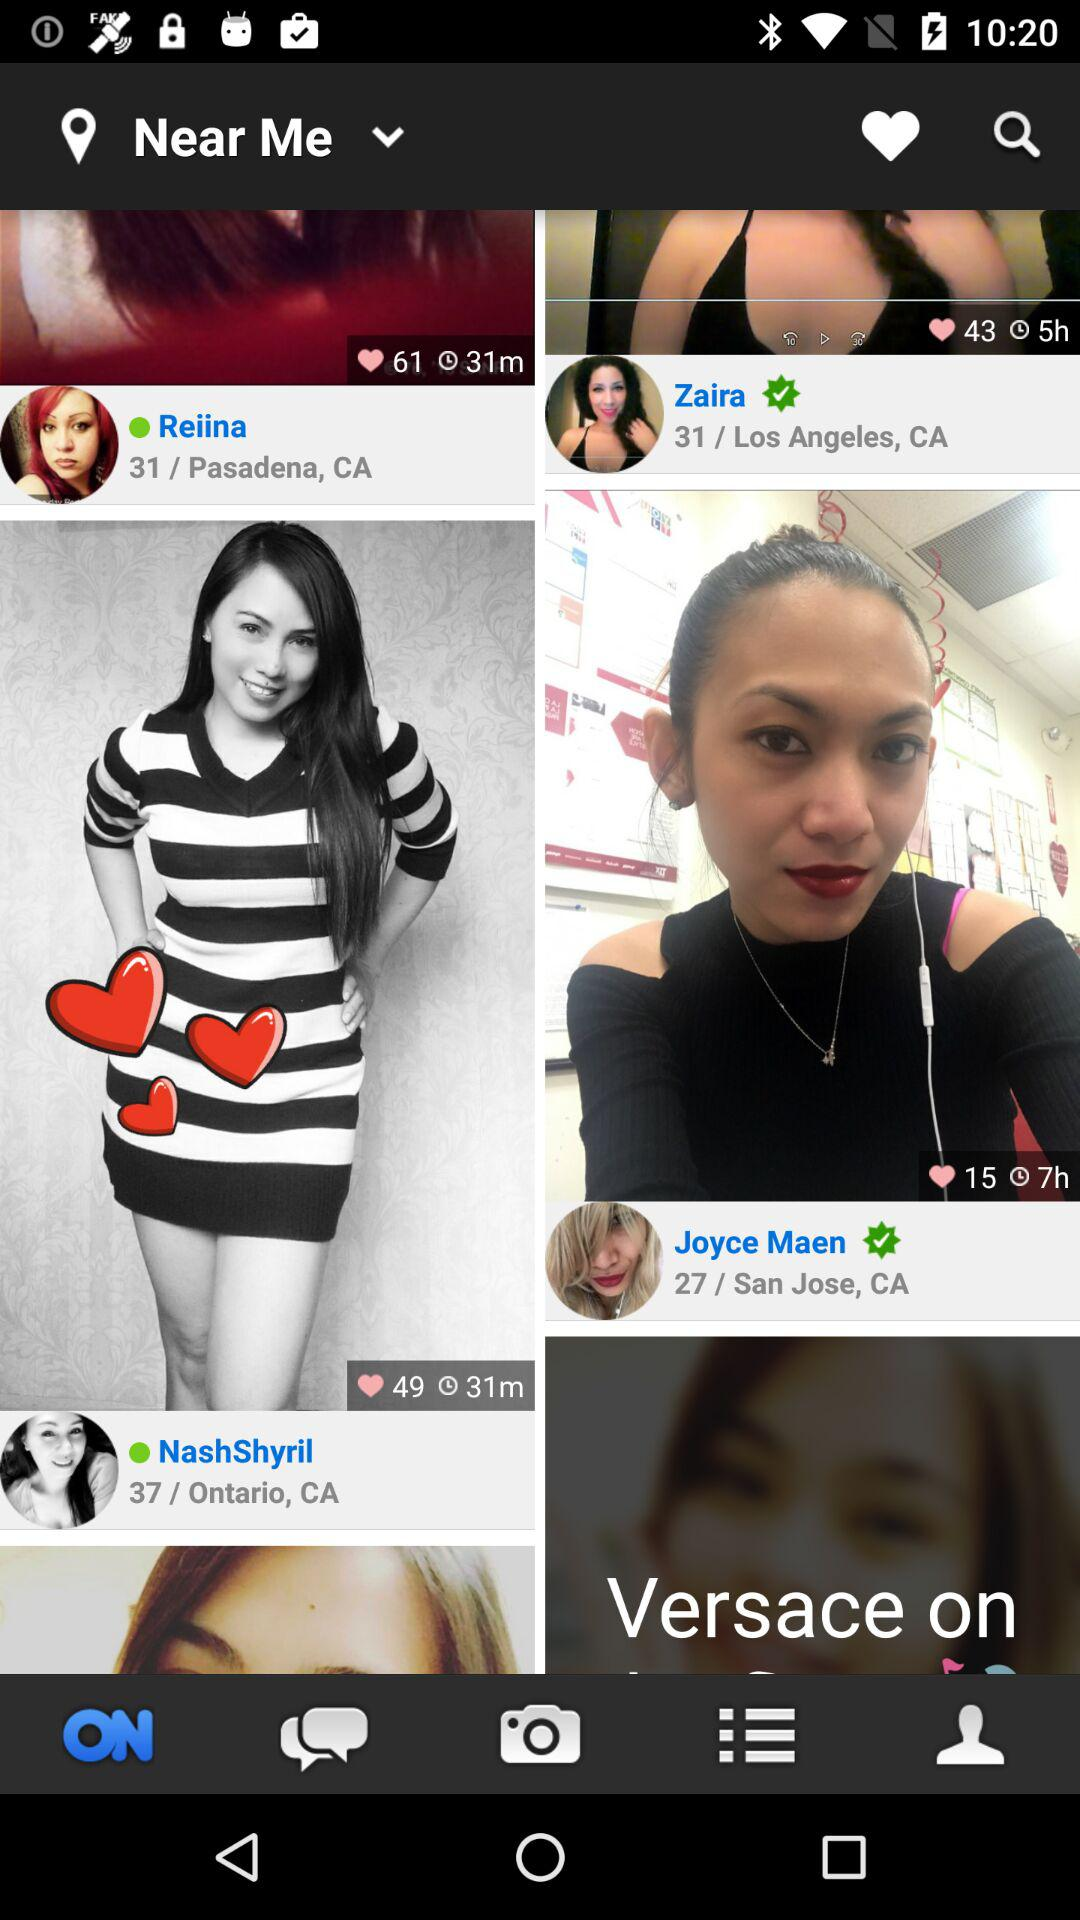Whose age is below 30? The person's name is Joyce Maen, who is under 30. 